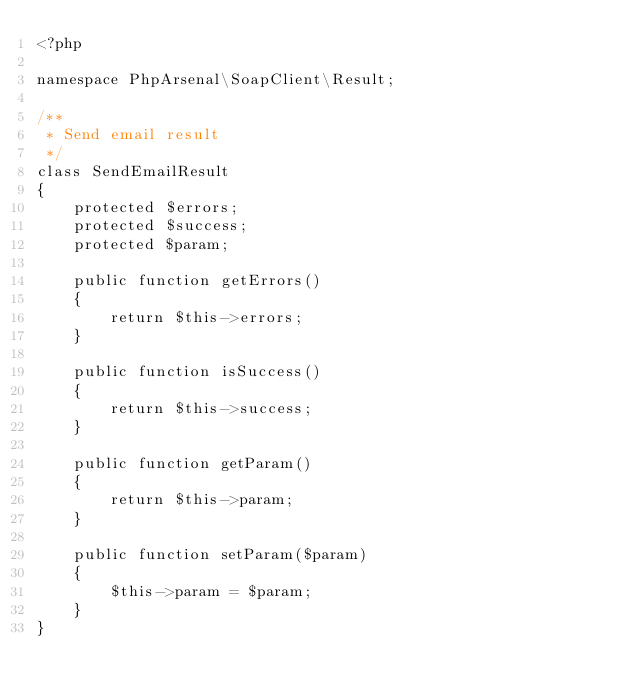Convert code to text. <code><loc_0><loc_0><loc_500><loc_500><_PHP_><?php

namespace PhpArsenal\SoapClient\Result;

/**
 * Send email result
 */
class SendEmailResult 
{
    protected $errors;
    protected $success;
    protected $param;

    public function getErrors()
    {
        return $this->errors;
    }

    public function isSuccess()
    {
        return $this->success;
    }

    public function getParam()
    {
        return $this->param;
    }

    public function setParam($param)
    {
        $this->param = $param;
    }
}</code> 